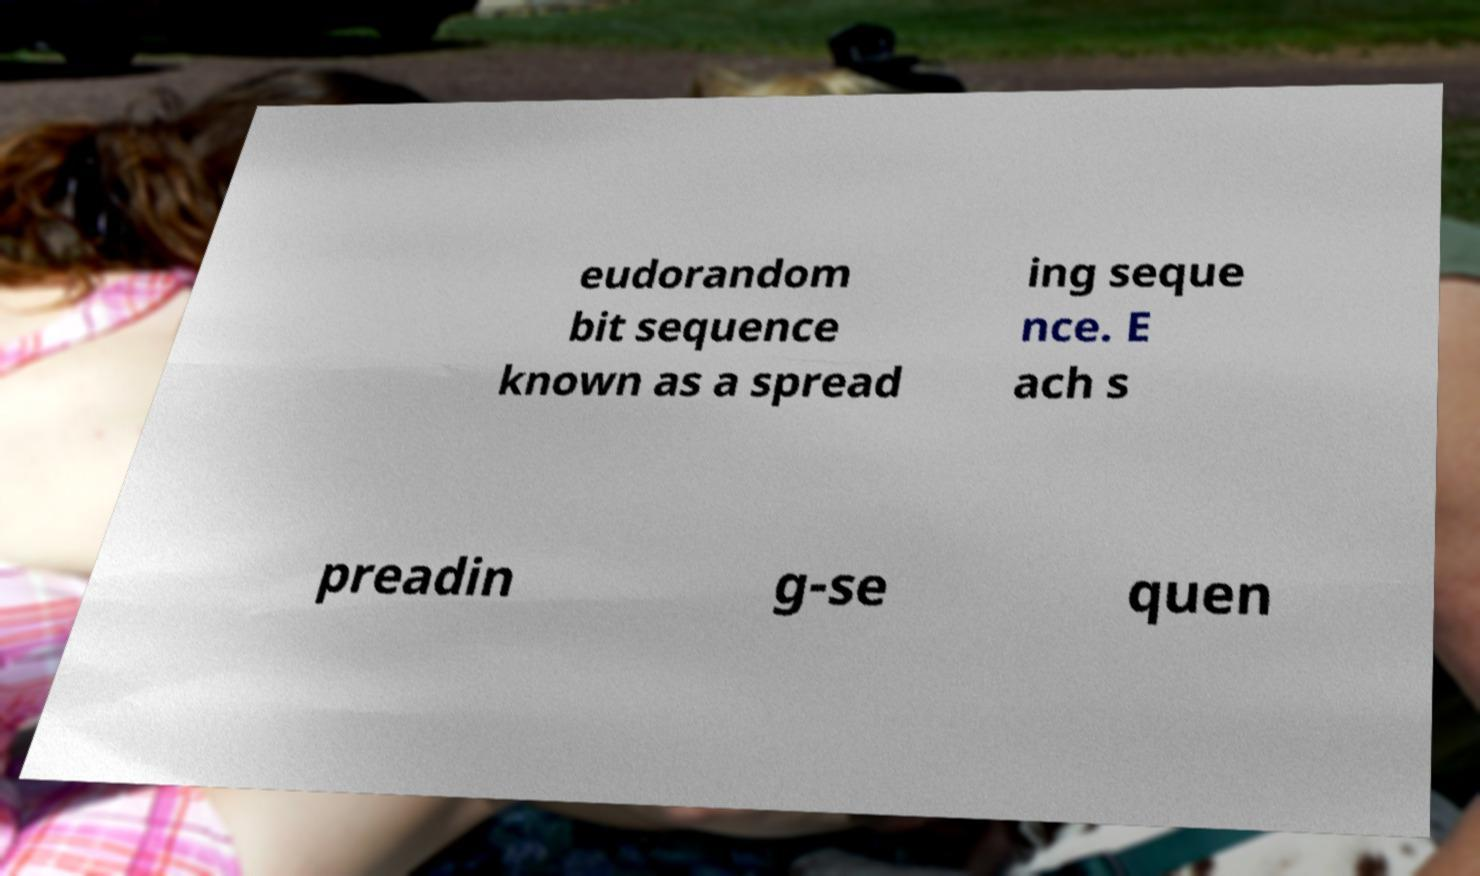Can you read and provide the text displayed in the image?This photo seems to have some interesting text. Can you extract and type it out for me? eudorandom bit sequence known as a spread ing seque nce. E ach s preadin g-se quen 